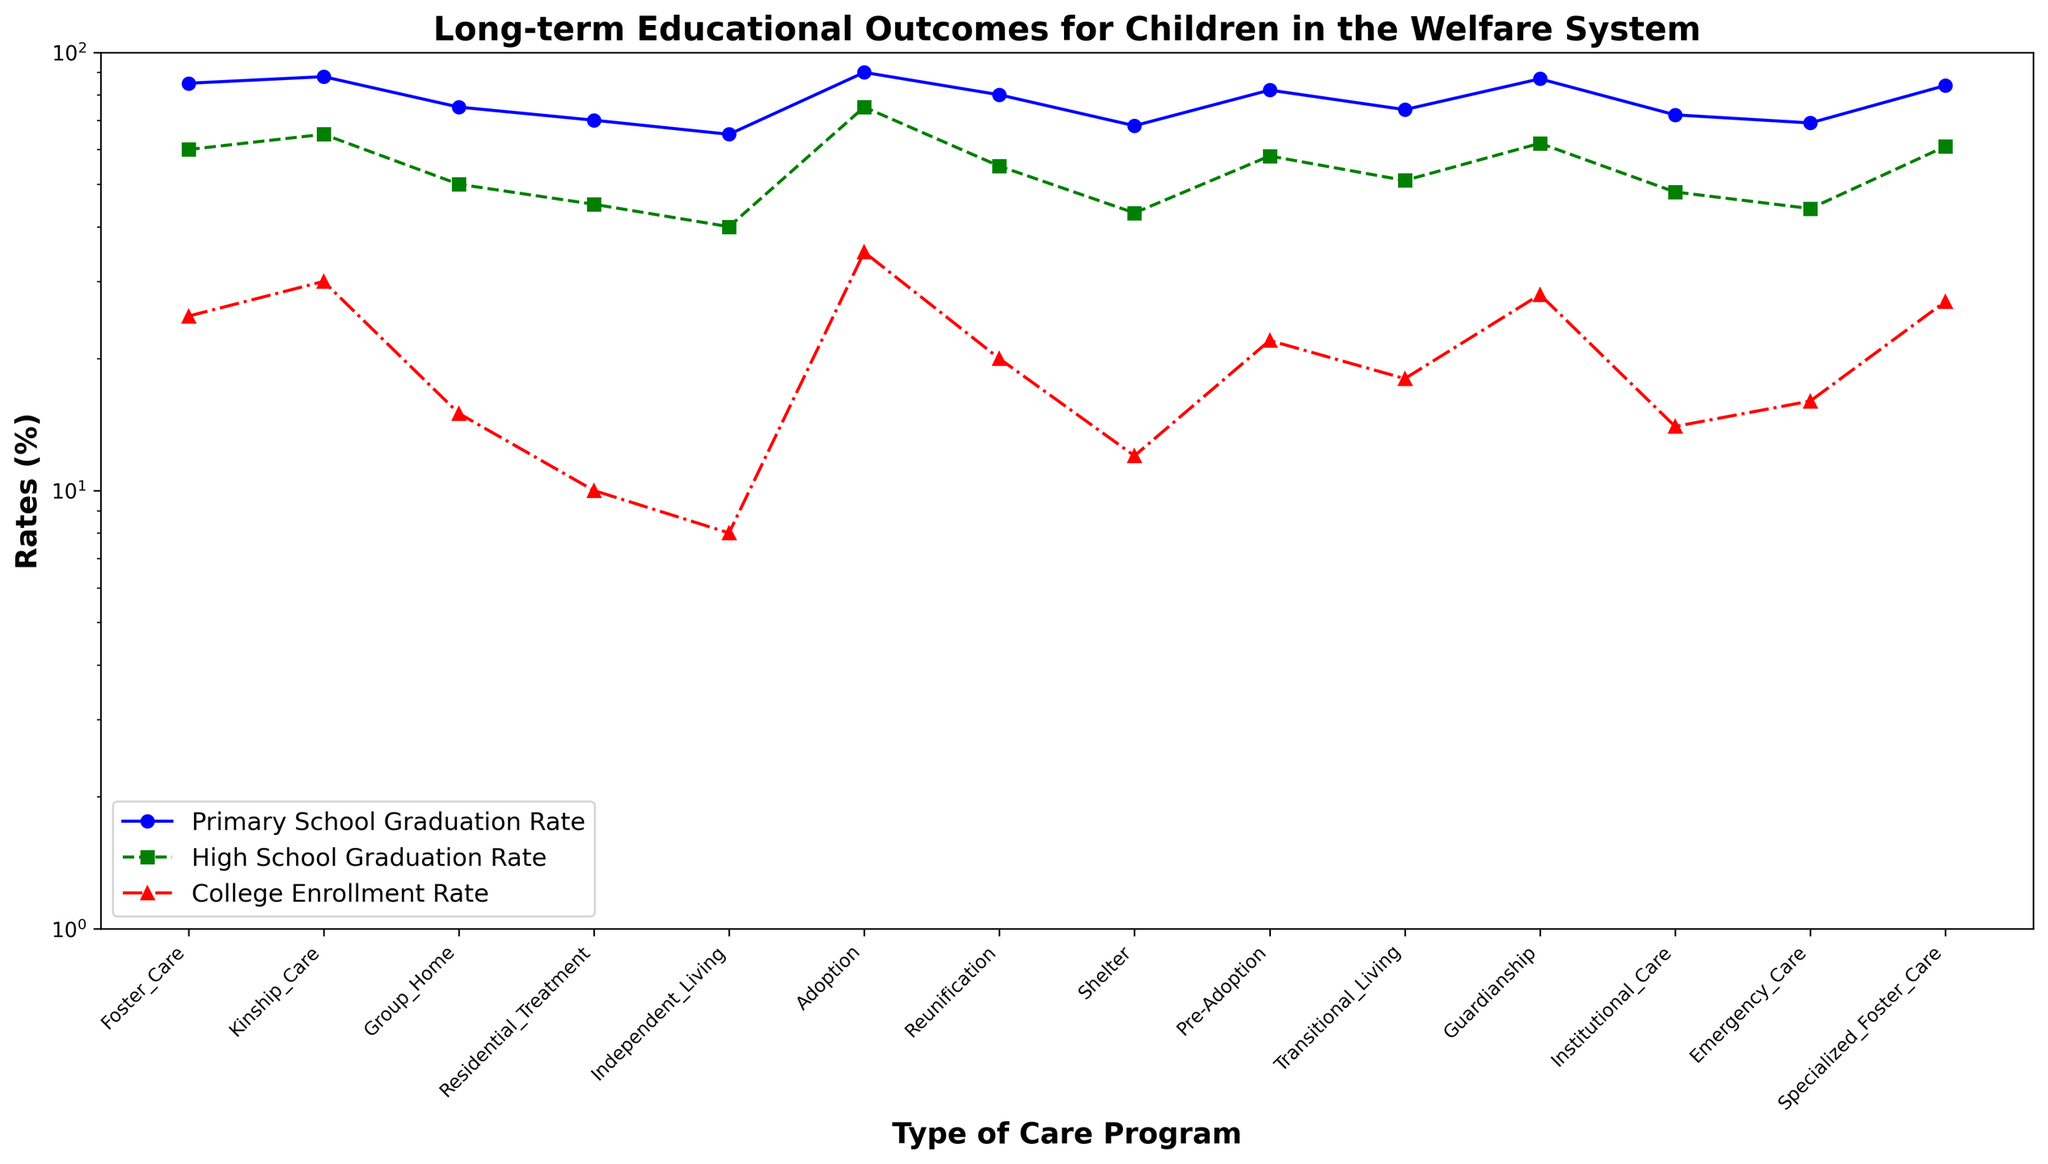Which care program has the highest primary school graduation rate? From the three lines, identify the blue line representing primary school graduation rates. Look for the peak point of the blue line, which falls on "Adoption".
Answer: Adoption What is the difference in high school graduation rates between Foster Care and Independent Living? Locate the green squares on the graph for Foster Care and Independent Living. Foster Care is at 60%, and Independent Living is at 40%. The difference is 60% - 40% = 20%.
Answer: 20% Which care program has the lowest college enrollment rate? Examine the red triangles representing college enrollment rates. The lowest red triangle falls by the label "Independent Living".
Answer: Independent Living Is the college enrollment rate for Kinship Care higher or lower than for Specialized Foster Care? Compare the red triangles for Kinship Care and Specialized Foster Care. Kinship Care is at 30%, and Specialized Foster Care is at 27%. Kinship Care is higher.
Answer: Higher Which care programs have a primary school graduation rate greater than 80% and a high school graduation rate less than 60%? For each care program, check if the blue line is above 80% and the green line is below 60%. "Pre-Adoption" meets this criterion: Primary School Graduation Rate (82%), High School Graduation Rate (58%).
Answer: Pre-Adoption What’s the average college enrollment rate for Group Home, Residential Treatment, and Shelter? Identify the red triangles for these three programs: Group Home (15%), Residential Treatment (10%), Shelter (12%). Add them up: 15 + 10 + 12 = 37. Divide by 3 to get the average: 37 / 3 ≈ 12.33.
Answer: 12.33 Does Reunification have a higher high school graduation rate than Transitional Living? Compare the green squares for Reunification (55%) and Transitional Living (51%). Reunification has a higher rate.
Answer: Yes List all programs with a primary school graduation rate below 70%. Identify the blue line points below 70%: Shelter (68%), Residential Treatment (70%), and Independent Living (65%). Note that Independent Living and Shelter are below 70%, Residential Treatment is exactly 70%.
Answer: Shelter and Independent Living What is the ratio of primary school graduation rates between Adoption and Group Home? Find the blue line points for Adoption (90%) and Group Home (75%). Calculate the ratio: 90 / 75 = 1.2.
Answer: 1.2 Are there any programs where the college enrollment rates are equal and if yes, which ones? Check the red triangles for equal values. Both Independent Living and Shelter have a rate of 12%, having equal college enrollment rates.
Answer: Yes, Independent Living and Shelter 